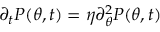<formula> <loc_0><loc_0><loc_500><loc_500>\partial _ { t } P ( \theta , t ) = \eta \partial _ { \theta } ^ { 2 } P ( \theta , t )</formula> 